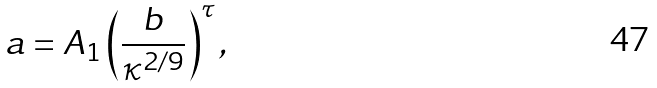<formula> <loc_0><loc_0><loc_500><loc_500>a = A _ { 1 } \left ( \frac { b } { \kappa ^ { 2 / 9 } } \right ) ^ { \tau } ,</formula> 